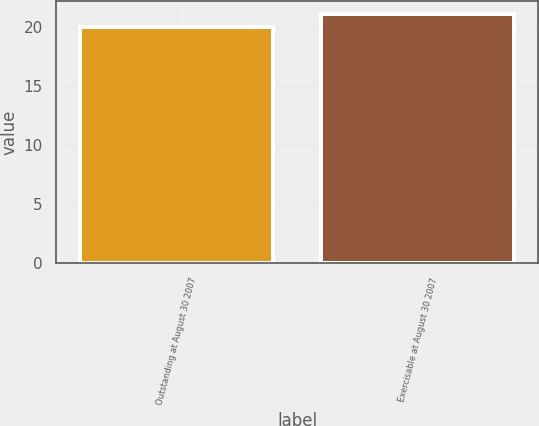<chart> <loc_0><loc_0><loc_500><loc_500><bar_chart><fcel>Outstanding at August 30 2007<fcel>Exercisable at August 30 2007<nl><fcel>20<fcel>21.12<nl></chart> 